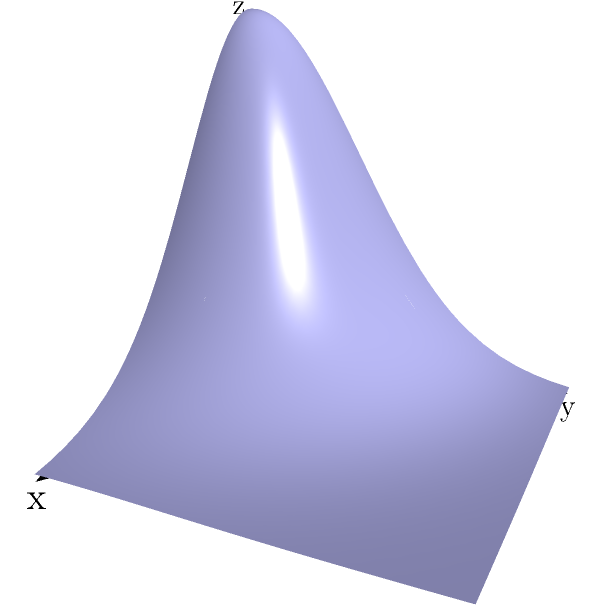Calculate the volume of the solid bounded by the surface $z = 2e^{-x^2-y^2}$ and the xy-plane over the region $R: 0 \leq x \leq 2, 0 \leq y \leq 2$. Express your answer in terms of $\pi$ and $\text{erf}(x)$, where $\text{erf}(x)$ is the error function defined as $\text{erf}(x) = \frac{2}{\sqrt{\pi}} \int_0^x e^{-t^2} dt$. To calculate the volume, we need to set up a double integral over the given region:

1) The volume is given by:
   $$V = \int\int_R 2e^{-x^2-y^2} dA$$

2) Set up the double integral:
   $$V = \int_0^2 \int_0^2 2e^{-x^2-y^2} dy dx$$

3) To evaluate this, let's first integrate with respect to y:
   $$V = \int_0^2 \left[-\sqrt{\pi} \cdot \text{erf}(y)\right]_0^2 \cdot e^{-x^2} dx$$

4) Evaluate the inner integral:
   $$V = \sqrt{\pi} \int_0^2 (\text{erf}(2) - \text{erf}(0)) \cdot e^{-x^2} dx$$

5) Simplify, noting that $\text{erf}(0) = 0$:
   $$V = \sqrt{\pi} \cdot \text{erf}(2) \int_0^2 e^{-x^2} dx$$

6) The remaining integral is in the form of the error function:
   $$V = \sqrt{\pi} \cdot \text{erf}(2) \cdot \frac{\sqrt{\pi}}{2} \cdot \text{erf}(2)$$

7) Simplify:
   $$V = \frac{\pi}{2} \cdot [\text{erf}(2)]^2$$

This expression gives the volume in terms of $\pi$ and $\text{erf}(2)$.
Answer: $\frac{\pi}{2} \cdot [\text{erf}(2)]^2$ 